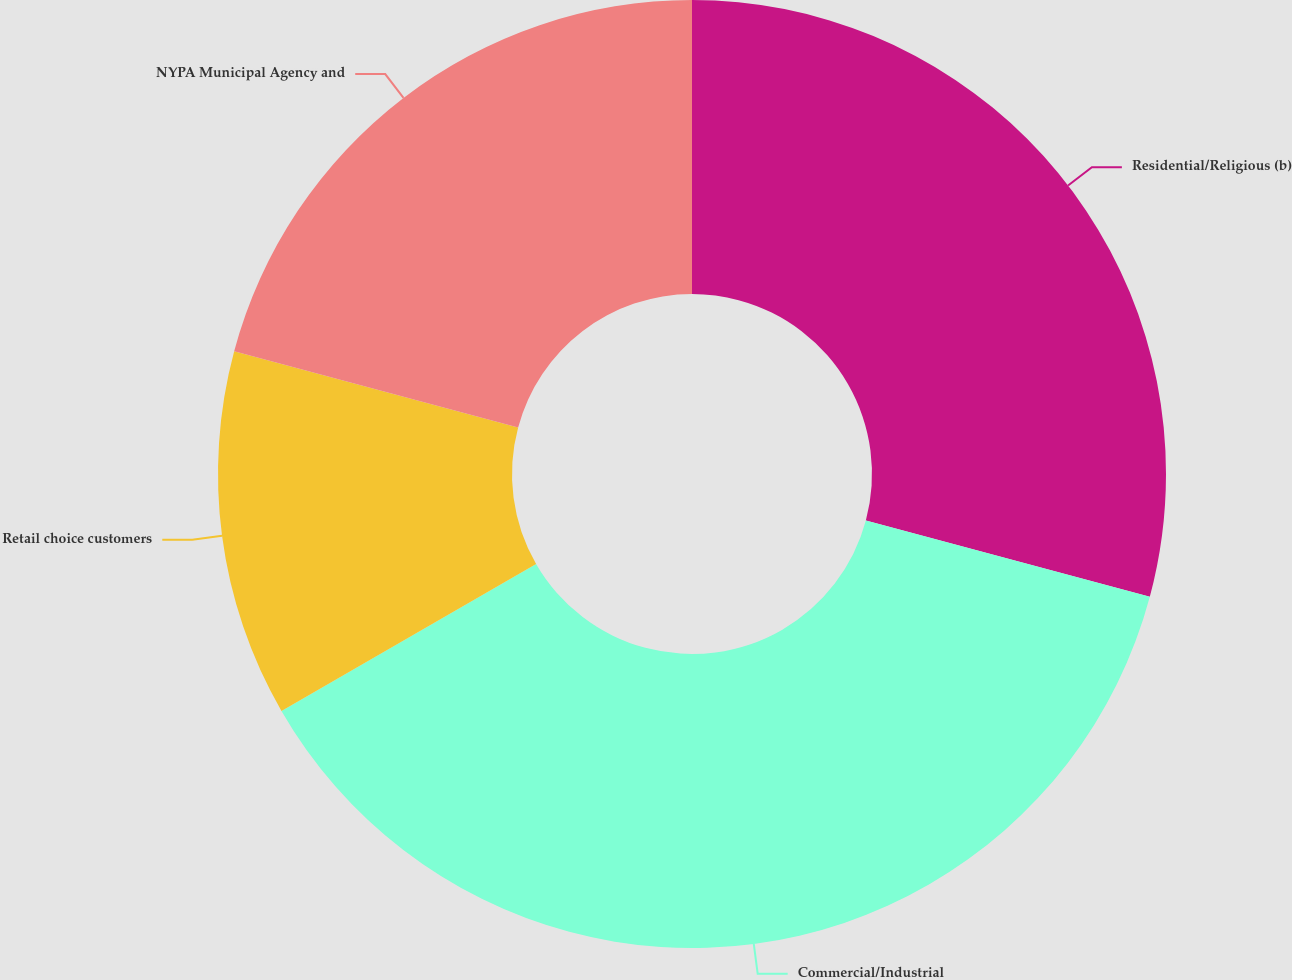Convert chart to OTSL. <chart><loc_0><loc_0><loc_500><loc_500><pie_chart><fcel>Residential/Religious (b)<fcel>Commercial/Industrial<fcel>Retail choice customers<fcel>NYPA Municipal Agency and<nl><fcel>29.17%<fcel>37.5%<fcel>12.5%<fcel>20.83%<nl></chart> 